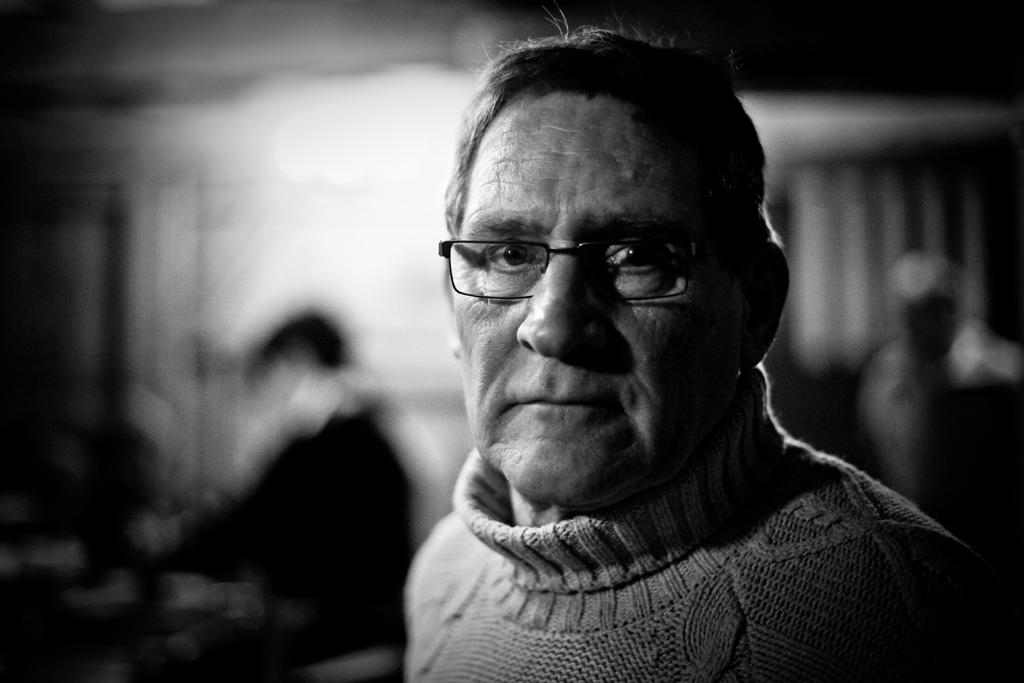What is the color scheme of the image? The image is black and white. Can you describe the person in the foreground of the image? There is a person wearing spectacles in the image. How many other people are visible in the image? There are two other persons visible behind the person with spectacles. What can be said about the background of the image? The background of the image is blurred. What type of force is being applied to the shelf in the image? There is no shelf present in the image, so no force is being applied to a shelf. Can you tell me how many thumbs are visible in the image? The number of thumbs visible in the image cannot be determined from the provided facts. 